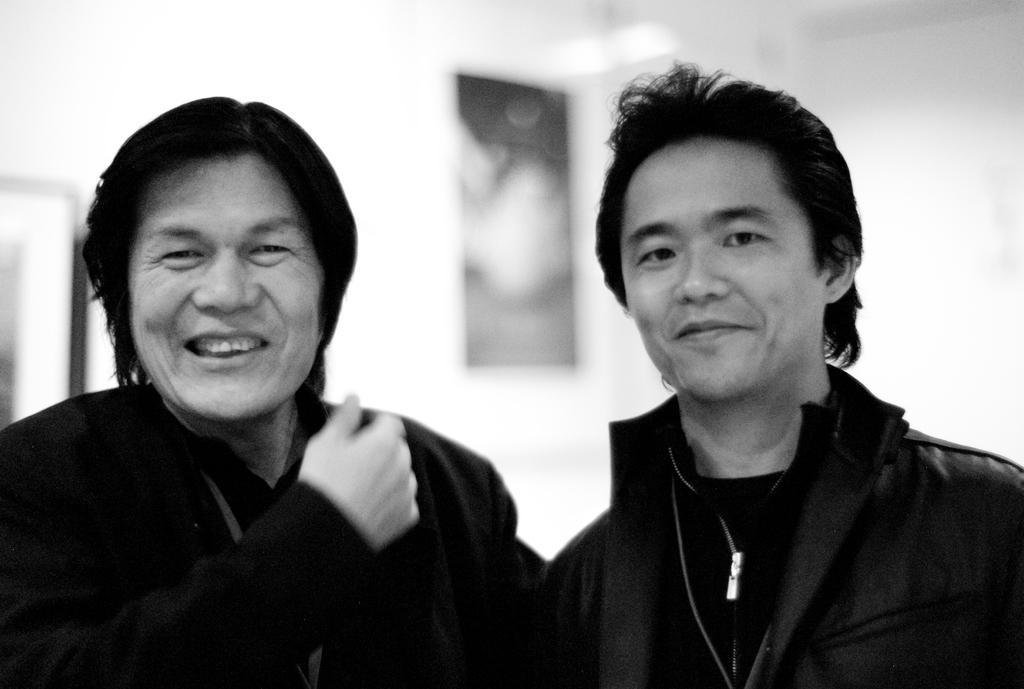What can be seen in the image regarding the people present? There are men standing in the image. How are the men depicted in terms of their expressions? The men have smiles on their faces. What can be observed in the background of the image? There appear to be photo frames on the back (background). What is the aftermath of the thumb war between the men in the image? There is no thumb war depicted in the image, so it's not possible to determine the aftermath. 